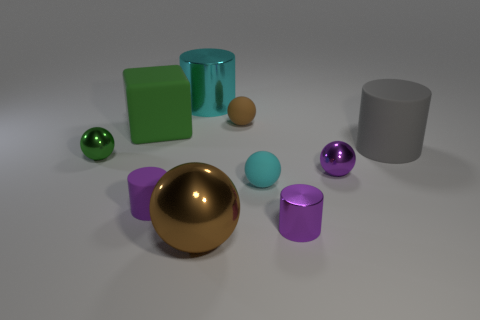Subtract 1 spheres. How many spheres are left? 4 Subtract all cyan cylinders. How many cylinders are left? 3 Subtract all purple metal balls. How many balls are left? 4 Subtract all red cylinders. Subtract all green blocks. How many cylinders are left? 4 Subtract all cylinders. How many objects are left? 6 Subtract all cyan cylinders. Subtract all tiny brown rubber balls. How many objects are left? 8 Add 4 rubber balls. How many rubber balls are left? 6 Add 4 big brown metallic objects. How many big brown metallic objects exist? 5 Subtract 0 yellow spheres. How many objects are left? 10 